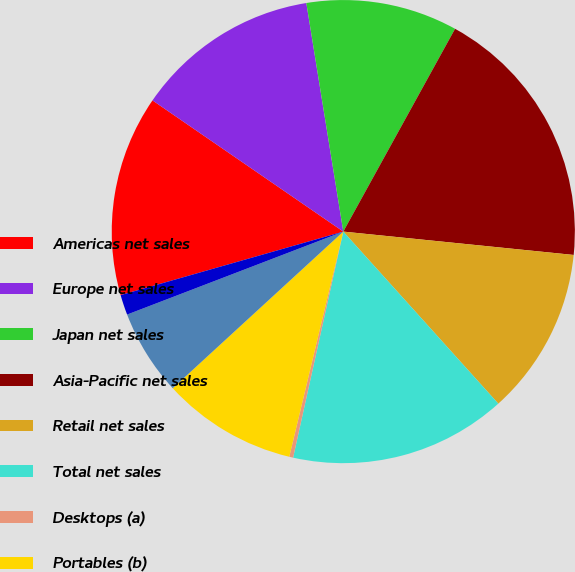Convert chart. <chart><loc_0><loc_0><loc_500><loc_500><pie_chart><fcel>Americas net sales<fcel>Europe net sales<fcel>Japan net sales<fcel>Asia-Pacific net sales<fcel>Retail net sales<fcel>Total net sales<fcel>Desktops (a)<fcel>Portables (b)<fcel>Total Mac net sales<fcel>iPod<nl><fcel>14.01%<fcel>12.86%<fcel>10.57%<fcel>18.59%<fcel>11.72%<fcel>15.15%<fcel>0.27%<fcel>9.43%<fcel>5.99%<fcel>1.41%<nl></chart> 